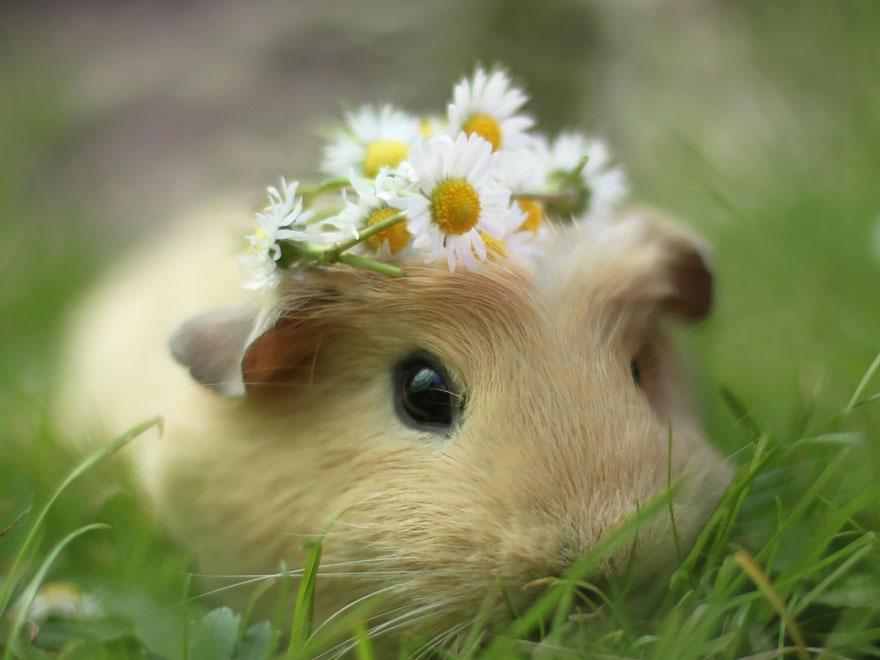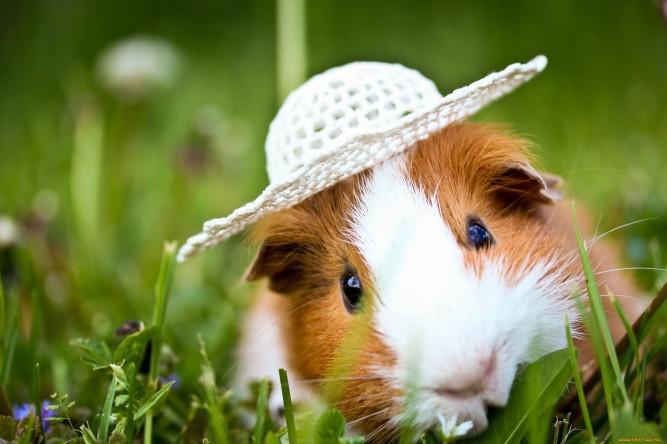The first image is the image on the left, the second image is the image on the right. Analyze the images presented: Is the assertion "At least one guinea pig has a brown face with a white stripe." valid? Answer yes or no. Yes. 